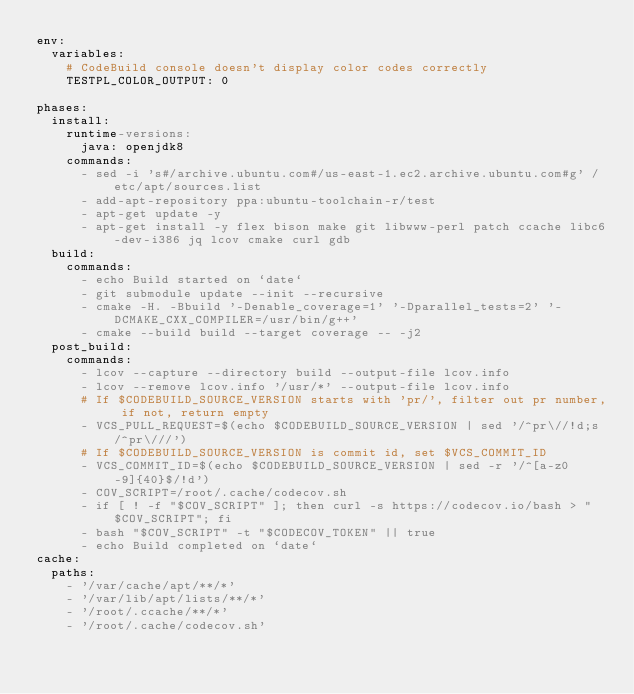<code> <loc_0><loc_0><loc_500><loc_500><_YAML_>env:
  variables:
    # CodeBuild console doesn't display color codes correctly
    TESTPL_COLOR_OUTPUT: 0

phases:
  install:
    runtime-versions:
      java: openjdk8    
    commands:
      - sed -i 's#/archive.ubuntu.com#/us-east-1.ec2.archive.ubuntu.com#g' /etc/apt/sources.list
      - add-apt-repository ppa:ubuntu-toolchain-r/test
      - apt-get update -y
      - apt-get install -y flex bison make git libwww-perl patch ccache libc6-dev-i386 jq lcov cmake curl gdb
  build:
    commands:
      - echo Build started on `date`
      - git submodule update --init --recursive
      - cmake -H. -Bbuild '-Denable_coverage=1' '-Dparallel_tests=2' '-DCMAKE_CXX_COMPILER=/usr/bin/g++'
      - cmake --build build --target coverage -- -j2
  post_build:
    commands:
      - lcov --capture --directory build --output-file lcov.info
      - lcov --remove lcov.info '/usr/*' --output-file lcov.info
      # If $CODEBUILD_SOURCE_VERSION starts with 'pr/', filter out pr number, if not, return empty
      - VCS_PULL_REQUEST=$(echo $CODEBUILD_SOURCE_VERSION | sed '/^pr\//!d;s/^pr\///')
      # If $CODEBUILD_SOURCE_VERSION is commit id, set $VCS_COMMIT_ID
      - VCS_COMMIT_ID=$(echo $CODEBUILD_SOURCE_VERSION | sed -r '/^[a-z0-9]{40}$/!d')
      - COV_SCRIPT=/root/.cache/codecov.sh
      - if [ ! -f "$COV_SCRIPT" ]; then curl -s https://codecov.io/bash > "$COV_SCRIPT"; fi
      - bash "$COV_SCRIPT" -t "$CODECOV_TOKEN" || true
      - echo Build completed on `date`
cache:
  paths:
    - '/var/cache/apt/**/*'
    - '/var/lib/apt/lists/**/*'
    - '/root/.ccache/**/*'
    - '/root/.cache/codecov.sh'
</code> 